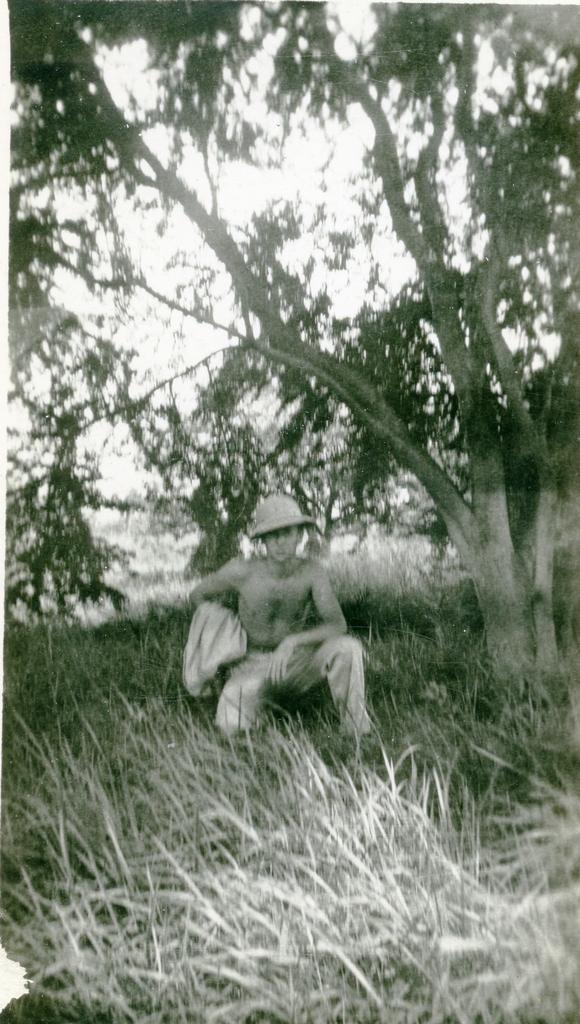Who is present in the image? There is a man in the image. What is the man doing in the image? The man is sitting on the grass in a squatting position. What can be seen near the man in the image? There is a big tree beside the man. What is the man's annual income in the image? There is no information about the man's income in the image. 